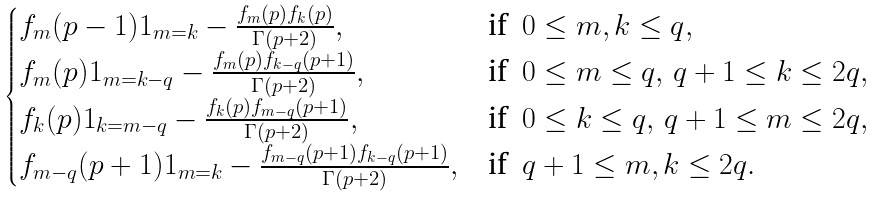<formula> <loc_0><loc_0><loc_500><loc_500>\begin{cases} f _ { m } ( p - 1 ) 1 _ { m = k } - \frac { f _ { m } ( p ) f _ { k } ( p ) } { \Gamma ( p + 2 ) } , & \text {if} \ \ 0 \leq m , k \leq q , \\ f _ { m } ( p ) 1 _ { m = k - q } - \frac { f _ { m } ( p ) f _ { k - q } ( p + 1 ) } { \Gamma ( p + 2 ) } , & \text {if} \ \ 0 \leq m \leq q , \, q + 1 \leq k \leq 2 q , \\ f _ { k } ( p ) 1 _ { k = m - q } - \frac { f _ { k } ( p ) f _ { m - q } ( p + 1 ) } { \Gamma ( p + 2 ) } , & \text {if} \ \ 0 \leq k \leq q , \, q + 1 \leq m \leq 2 q , \\ f _ { m - q } ( p + 1 ) 1 _ { m = k } - \frac { f _ { m - q } ( p + 1 ) f _ { k - q } ( p + 1 ) } { \Gamma ( p + 2 ) } , & \text {if} \ \ q + 1 \leq m , k \leq 2 q . \end{cases}</formula> 